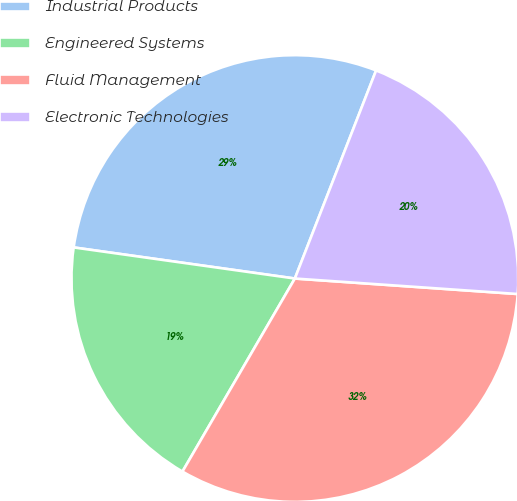<chart> <loc_0><loc_0><loc_500><loc_500><pie_chart><fcel>Industrial Products<fcel>Engineered Systems<fcel>Fluid Management<fcel>Electronic Technologies<nl><fcel>28.7%<fcel>18.83%<fcel>32.29%<fcel>20.18%<nl></chart> 